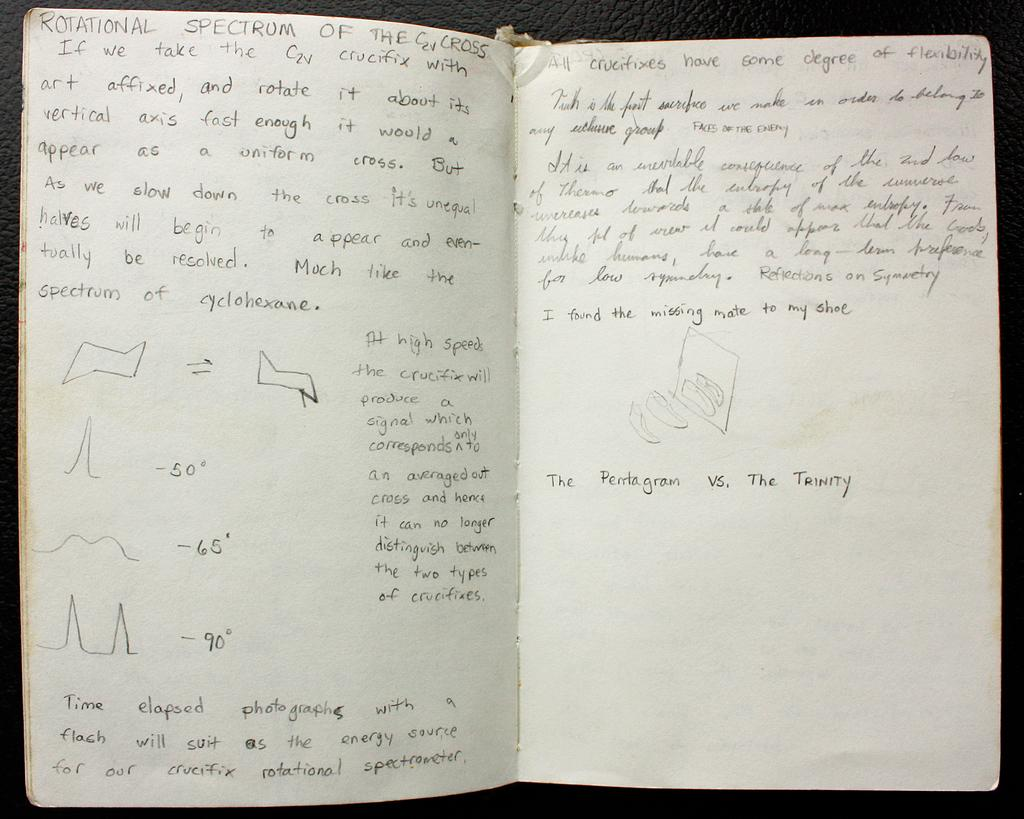<image>
Describe the image concisely. A notebook opened to show notes related to the rotational spectrum of a cross 